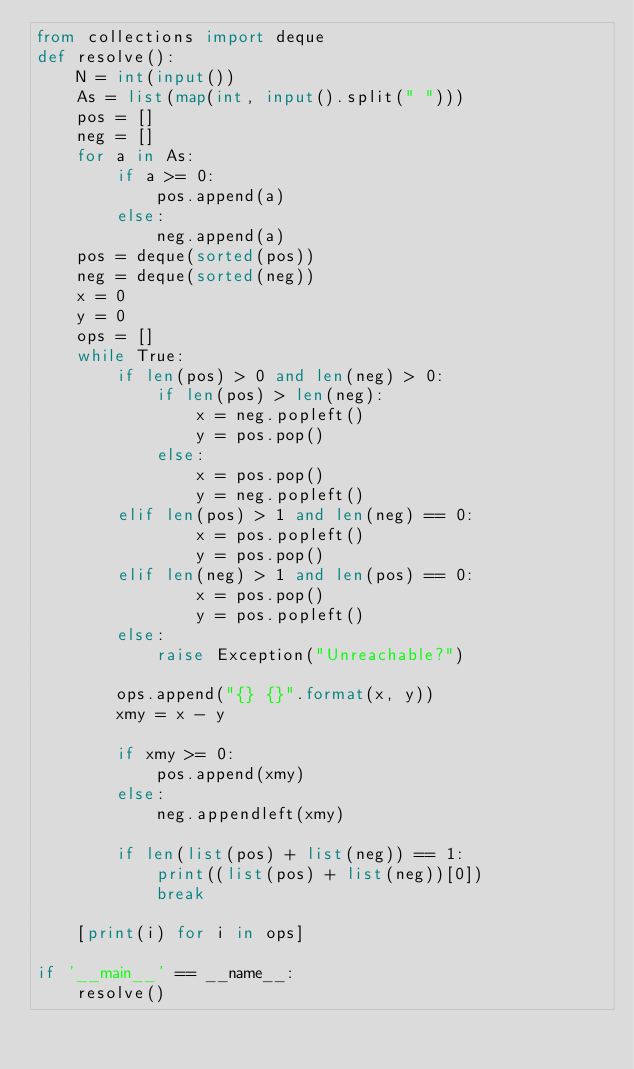Convert code to text. <code><loc_0><loc_0><loc_500><loc_500><_Python_>from collections import deque
def resolve():
    N = int(input())
    As = list(map(int, input().split(" ")))
    pos = []
    neg = []
    for a in As:
        if a >= 0:
            pos.append(a)
        else:
            neg.append(a)
    pos = deque(sorted(pos))
    neg = deque(sorted(neg))
    x = 0
    y = 0
    ops = []
    while True:
        if len(pos) > 0 and len(neg) > 0:
            if len(pos) > len(neg):
                x = neg.popleft()
                y = pos.pop()
            else:
                x = pos.pop()
                y = neg.popleft()
        elif len(pos) > 1 and len(neg) == 0:
                x = pos.popleft()
                y = pos.pop()
        elif len(neg) > 1 and len(pos) == 0:
                x = pos.pop()
                y = pos.popleft()
        else:
            raise Exception("Unreachable?")
        
        ops.append("{} {}".format(x, y))
        xmy = x - y

        if xmy >= 0:
            pos.append(xmy)
        else:
            neg.appendleft(xmy)
        
        if len(list(pos) + list(neg)) == 1:
            print((list(pos) + list(neg))[0])
            break
    
    [print(i) for i in ops]

if '__main__' == __name__:
    resolve()</code> 